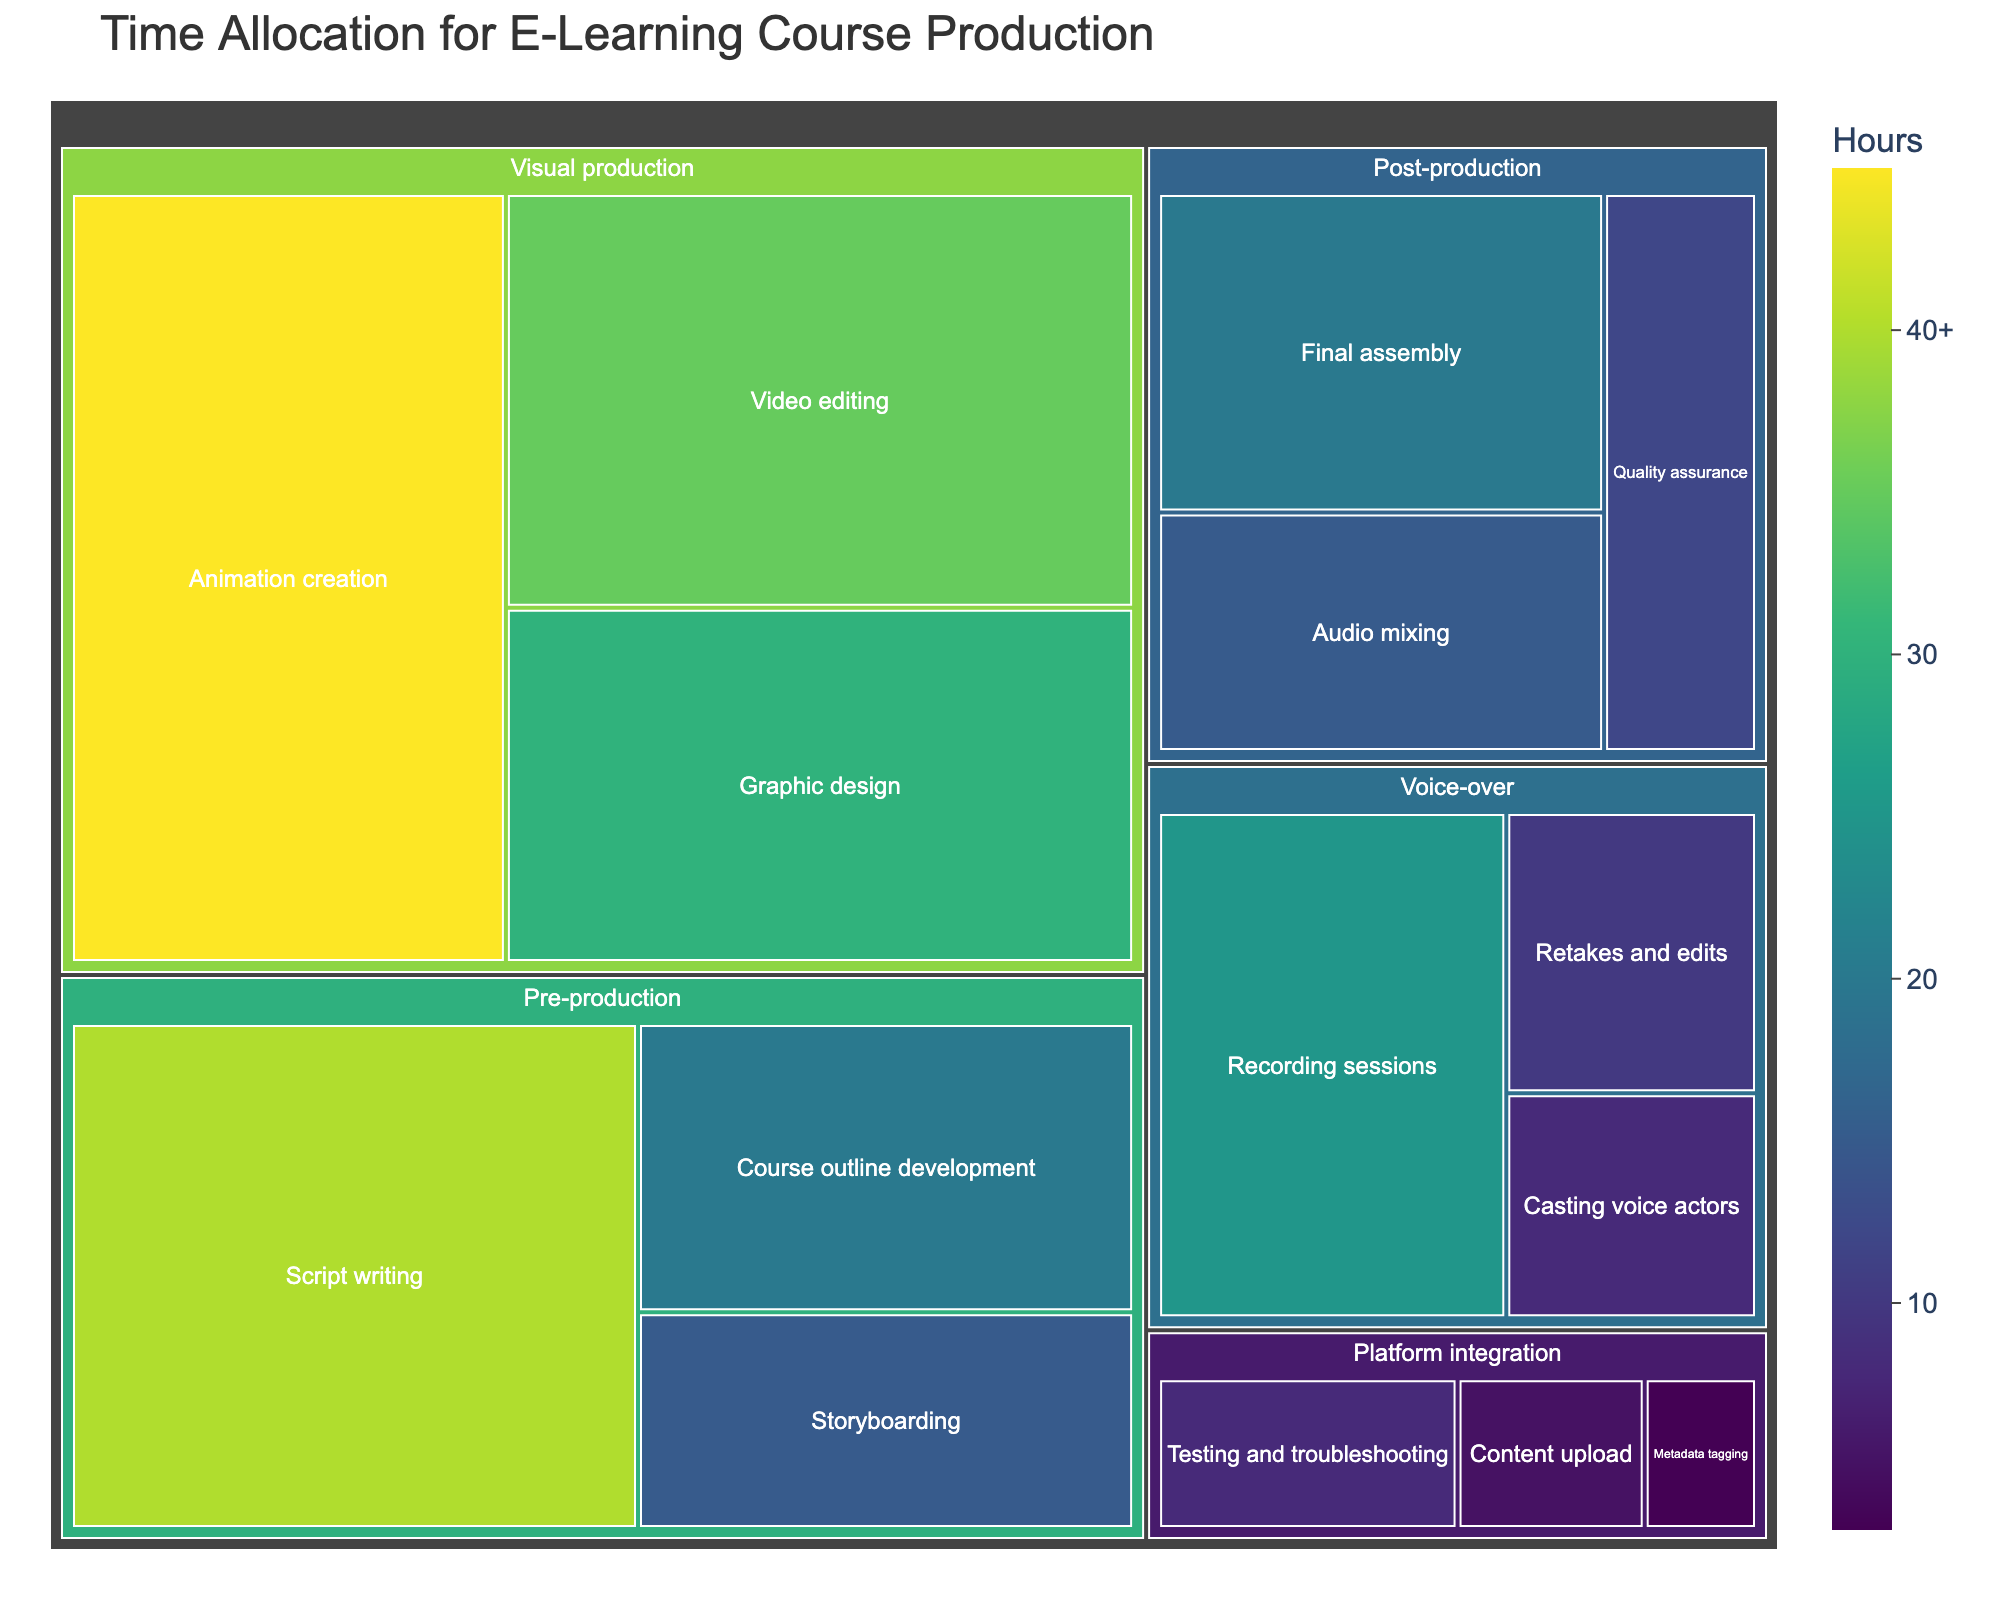What is the title of the treemap? The title of the treemap is displayed prominently at the top of the figure, usually larger in size compared to the other text.
Answer: Time Allocation for E-Learning Course Production How much time is allocated for the "Voice-over" stage in total? To find the total time for the "Voice-over" stage, add the time spent on each subprocess under this stage: Casting voice actors (8 hours), Recording sessions (25 hours), and Retakes and edits (10 hours).
Answer: 43 hours Which subprocess takes the most time in the "Visual production" stage? In the "Visual production" stage, compare the time for each subprocess: Graphic design (30 hours), Animation creation (45 hours), and Video editing (35 hours). Animation creation has the highest value.
Answer: Animation creation What is the time difference between "Content upload" and "Script writing"? "Content upload" is in the "Platform integration" stage (5 hours) and "Script writing" is in the "Pre-production" stage (40 hours). Subtract the smaller value from the larger one: 40 - 5 = 35 hours.
Answer: 35 hours Which subprocess in the "Post-production" stage has the least time allocation? Within the "Post-production" stage, compare the time for each subprocess: Audio mixing (15 hours), Final assembly (20 hours), and Quality assurance (12 hours). Quality assurance is the least.
Answer: Quality assurance Summarize the combined time for "Pre-production" and "Platform integration" stages. Add the total time for each subprocess under "Pre-production" (Course outline development: 20 + Script writing: 40 + Storyboarding: 15) and "Platform integration" (Content upload: 5 + Metadata tagging: 3 + Testing and troubleshooting: 8).
Answer: 91 hours Which stage has the highest total time allocation, and how much is it? Calculate the total time for each stage: Pre-production (20 + 40 + 15), Voice-over (8 + 25 + 10), Visual production (30 + 45 + 35), Post-production (15 + 20 + 12), and Platform integration (5 + 3 + 8). The "Visual production" stage has the highest total time.
Answer: 110 hours How does the time allocation for "Storyboarding" compare to "Quality assurance"? "Storyboarding" in the "Pre-production" stage has 15 hours, while "Quality assurance" in the "Post-production" stage has 12 hours. Compare the two values: 15 is greater than 12.
Answer: Storyboarding > Quality assurance What is the average time allocation per subprocess in the "Voice-over" stage? To find the average time for the "Voice-over" stage, sum the times for each subprocess: Casting voice actors (8) + Recording sessions (25) + Retakes and edits (10) = 43 hours. Divide by the number of subprocesses: 43 / 3.
Answer: 14.33 hours 